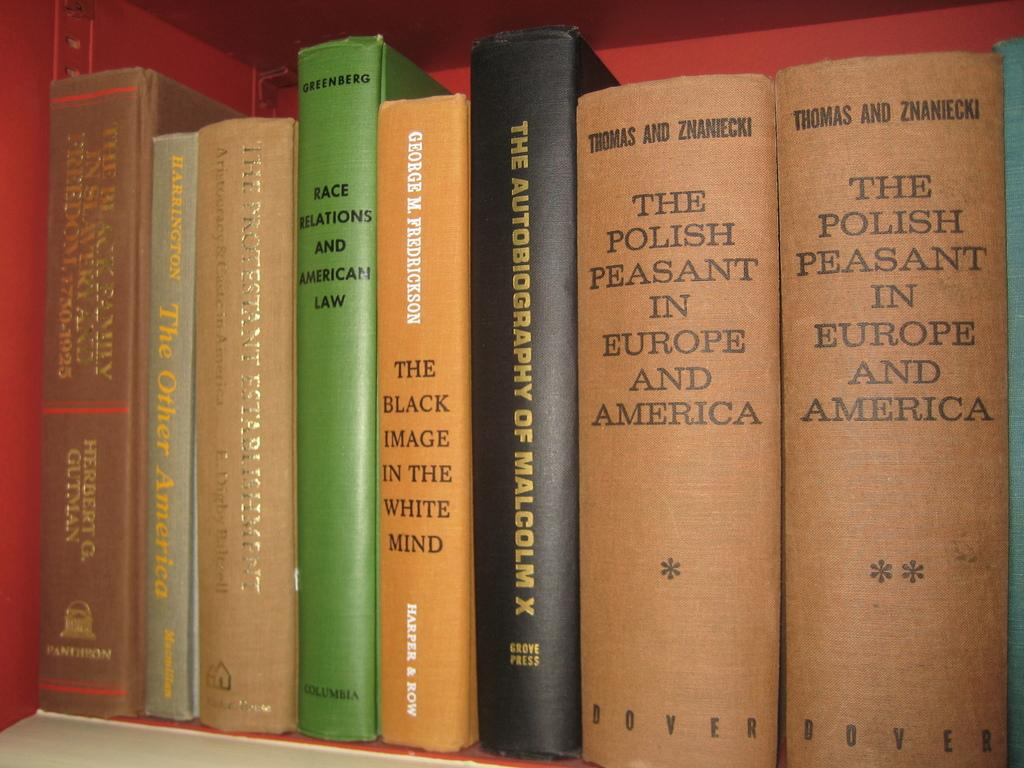<image>
Present a compact description of the photo's key features. Two volumes of, "The Polish Peasant in Europe and America" are on a bookshelf with other books. 